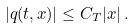<formula> <loc_0><loc_0><loc_500><loc_500>| q ( t , x ) | \leq C _ { T } | x | \, .</formula> 